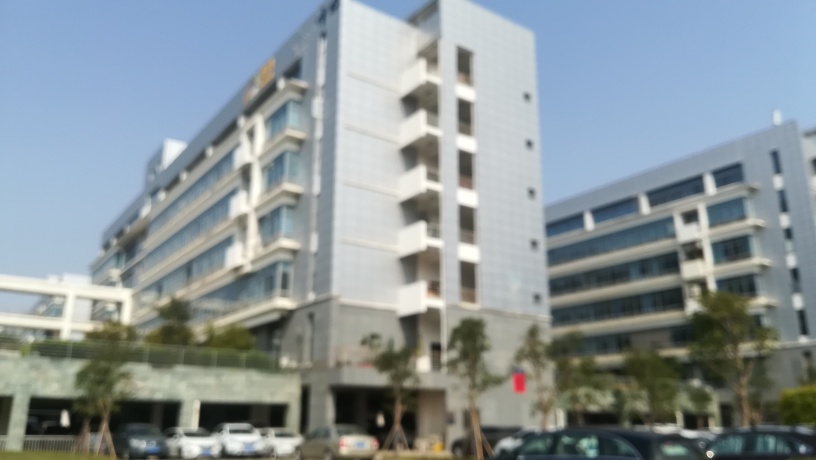Are there focusing issues in the image?
A. Yes
B. No
Answer with the option's letter from the given choices directly.
 A. 